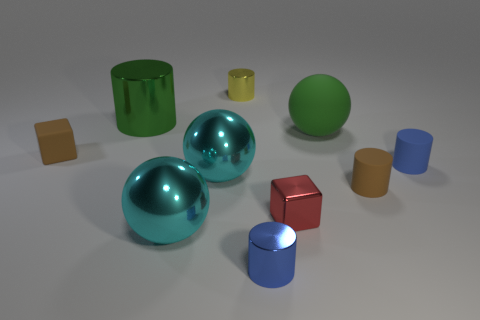Is there any other thing that has the same size as the rubber ball?
Offer a very short reply. Yes. There is a large metal object that is in front of the brown cylinder; what is its shape?
Provide a succinct answer. Sphere. How many other small shiny things have the same shape as the small yellow shiny thing?
Give a very brief answer. 1. Are there an equal number of metallic cylinders that are on the right side of the red shiny thing and rubber things that are on the left side of the small brown matte block?
Keep it short and to the point. Yes. Is there a big cylinder that has the same material as the small yellow cylinder?
Provide a short and direct response. Yes. Are the large green ball and the tiny brown cylinder made of the same material?
Ensure brevity in your answer.  Yes. What number of gray objects are large objects or rubber blocks?
Provide a succinct answer. 0. Are there more small brown cylinders that are behind the blue metallic cylinder than metallic spheres?
Give a very brief answer. No. Is there a tiny shiny cube that has the same color as the big matte sphere?
Provide a short and direct response. No. The green metal cylinder has what size?
Offer a terse response. Large. 